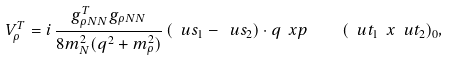<formula> <loc_0><loc_0><loc_500><loc_500>V _ { \rho } ^ { T } = i \, \frac { g ^ { T } _ { \rho N N } g _ { \rho N N } } { 8 m ^ { 2 } _ { N } ( { q } ^ { 2 } + m _ { \rho } ^ { 2 } ) } \, ( \ u s _ { 1 } - \ u s _ { 2 } ) \cdot { q } \ x { p } \quad ( \ u t _ { 1 } \ x \ u t _ { 2 } ) _ { 0 } ,</formula> 